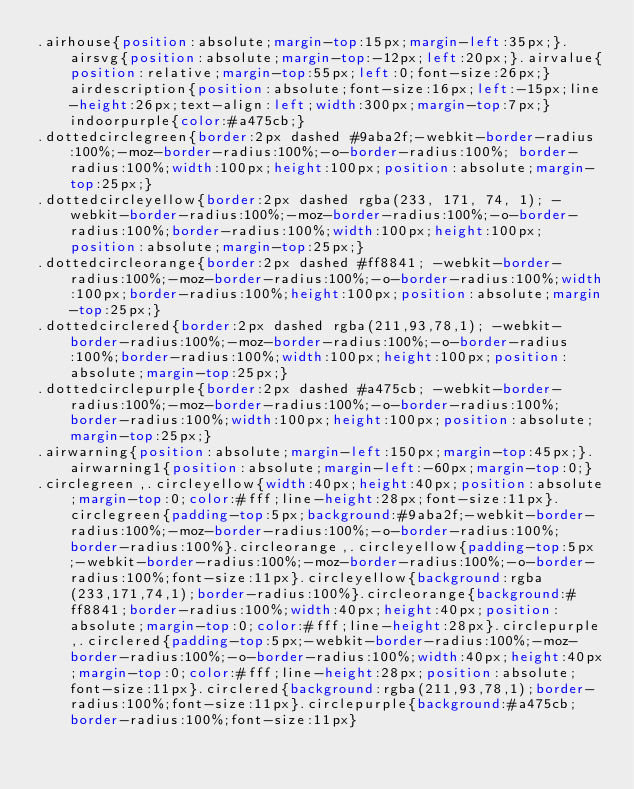Convert code to text. <code><loc_0><loc_0><loc_500><loc_500><_CSS_>.airhouse{position:absolute;margin-top:15px;margin-left:35px;}.airsvg{position:absolute;margin-top:-12px;left:20px;}.airvalue{position:relative;margin-top:55px;left:0;font-size:26px;}airdescription{position:absolute;font-size:16px;left:-15px;line-height:26px;text-align:left;width:300px;margin-top:7px;}indoorpurple{color:#a475cb;}
.dottedcirclegreen{border:2px dashed #9aba2f;-webkit-border-radius:100%;-moz-border-radius:100%;-o-border-radius:100%; border-radius:100%;width:100px;height:100px;position:absolute;margin-top:25px;}
.dottedcircleyellow{border:2px dashed rgba(233, 171, 74, 1); -webkit-border-radius:100%;-moz-border-radius:100%;-o-border-radius:100%;border-radius:100%;width:100px;height:100px;position:absolute;margin-top:25px;}
.dottedcircleorange{border:2px dashed #ff8841; -webkit-border-radius:100%;-moz-border-radius:100%;-o-border-radius:100%;width:100px;border-radius:100%;height:100px;position:absolute;margin-top:25px;}
.dottedcirclered{border:2px dashed rgba(211,93,78,1); -webkit-border-radius:100%;-moz-border-radius:100%;-o-border-radius:100%;border-radius:100%;width:100px;height:100px;position:absolute;margin-top:25px;}
.dottedcirclepurple{border:2px dashed #a475cb; -webkit-border-radius:100%;-moz-border-radius:100%;-o-border-radius:100%;border-radius:100%;width:100px;height:100px;position:absolute;margin-top:25px;}
.airwarning{position:absolute;margin-left:150px;margin-top:45px;}.airwarning1{position:absolute;margin-left:-60px;margin-top:0;}
.circlegreen,.circleyellow{width:40px;height:40px;position:absolute;margin-top:0;color:#fff;line-height:28px;font-size:11px}.circlegreen{padding-top:5px;background:#9aba2f;-webkit-border-radius:100%;-moz-border-radius:100%;-o-border-radius:100%;border-radius:100%}.circleorange,.circleyellow{padding-top:5px;-webkit-border-radius:100%;-moz-border-radius:100%;-o-border-radius:100%;font-size:11px}.circleyellow{background:rgba(233,171,74,1);border-radius:100%}.circleorange{background:#ff8841;border-radius:100%;width:40px;height:40px;position:absolute;margin-top:0;color:#fff;line-height:28px}.circlepurple,.circlered{padding-top:5px;-webkit-border-radius:100%;-moz-border-radius:100%;-o-border-radius:100%;width:40px;height:40px;margin-top:0;color:#fff;line-height:28px;position:absolute;font-size:11px}.circlered{background:rgba(211,93,78,1);border-radius:100%;font-size:11px}.circlepurple{background:#a475cb;border-radius:100%;font-size:11px}</code> 